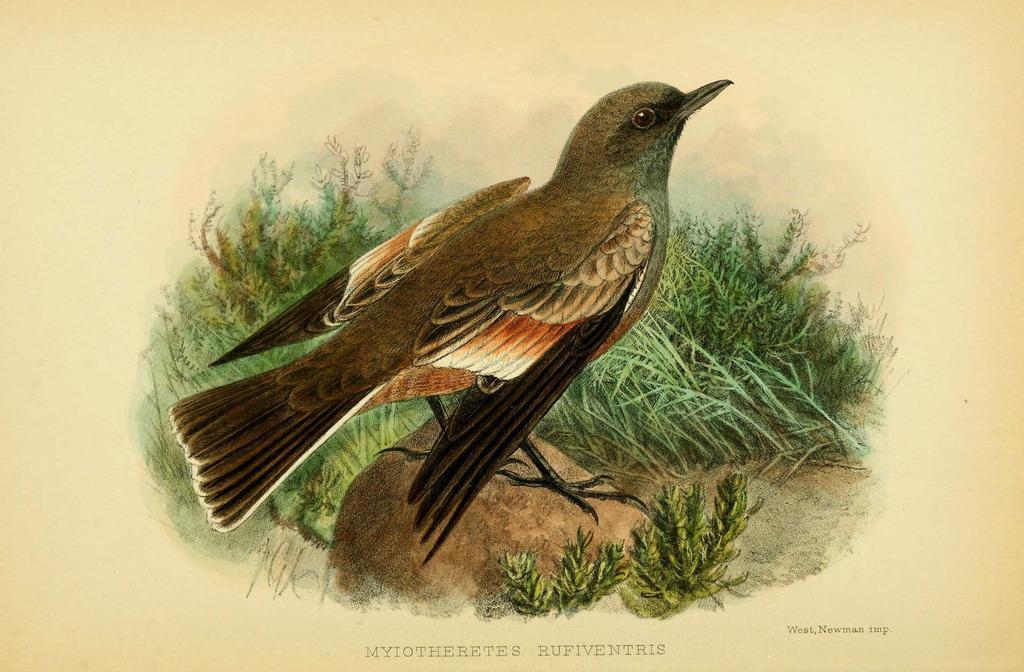Please provide a concise description of this image. In the image we can see a paper, on the paper there is a painting. 